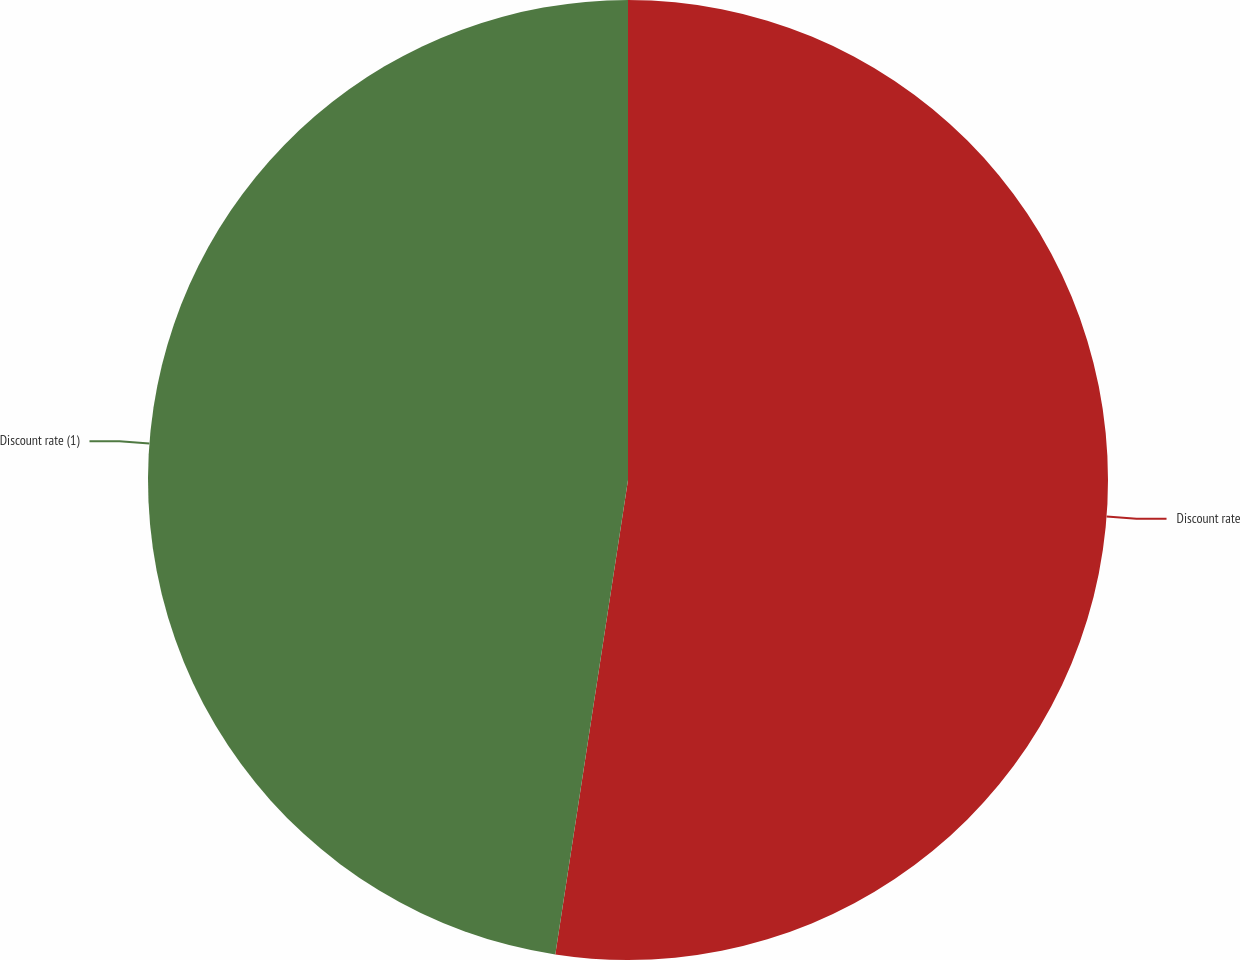Convert chart. <chart><loc_0><loc_0><loc_500><loc_500><pie_chart><fcel>Discount rate<fcel>Discount rate (1)<nl><fcel>52.42%<fcel>47.58%<nl></chart> 